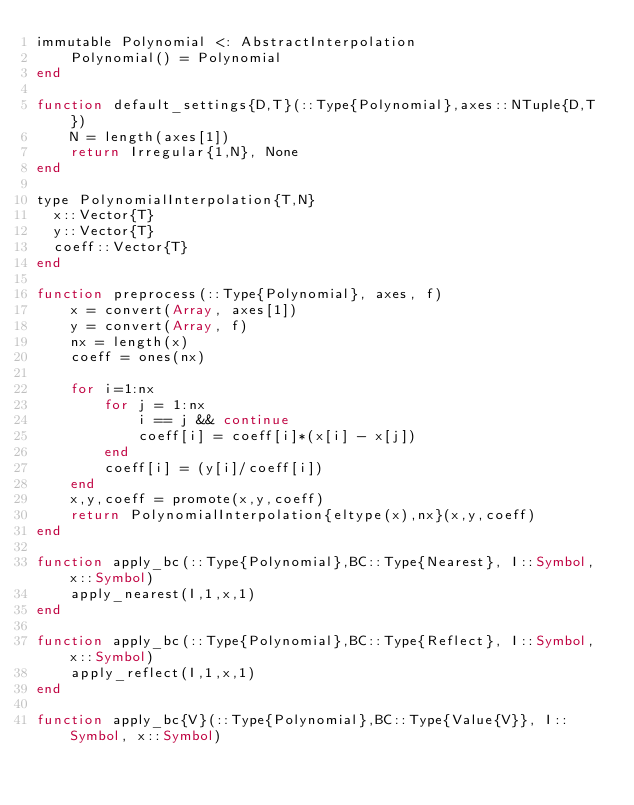<code> <loc_0><loc_0><loc_500><loc_500><_Julia_>immutable Polynomial <: AbstractInterpolation
    Polynomial() = Polynomial
end

function default_settings{D,T}(::Type{Polynomial},axes::NTuple{D,T})
    N = length(axes[1])
    return Irregular{1,N}, None
end

type PolynomialInterpolation{T,N}
  x::Vector{T}
  y::Vector{T}
  coeff::Vector{T}
end

function preprocess(::Type{Polynomial}, axes, f)
    x = convert(Array, axes[1])
    y = convert(Array, f)
    nx = length(x)
    coeff = ones(nx)

    for i=1:nx
        for j = 1:nx
            i == j && continue
            coeff[i] = coeff[i]*(x[i] - x[j])
        end
        coeff[i] = (y[i]/coeff[i])
    end
    x,y,coeff = promote(x,y,coeff)
    return PolynomialInterpolation{eltype(x),nx}(x,y,coeff)
end

function apply_bc(::Type{Polynomial},BC::Type{Nearest}, I::Symbol, x::Symbol)
    apply_nearest(I,1,x,1)
end

function apply_bc(::Type{Polynomial},BC::Type{Reflect}, I::Symbol, x::Symbol)
    apply_reflect(I,1,x,1)
end

function apply_bc{V}(::Type{Polynomial},BC::Type{Value{V}}, I::Symbol, x::Symbol)</code> 